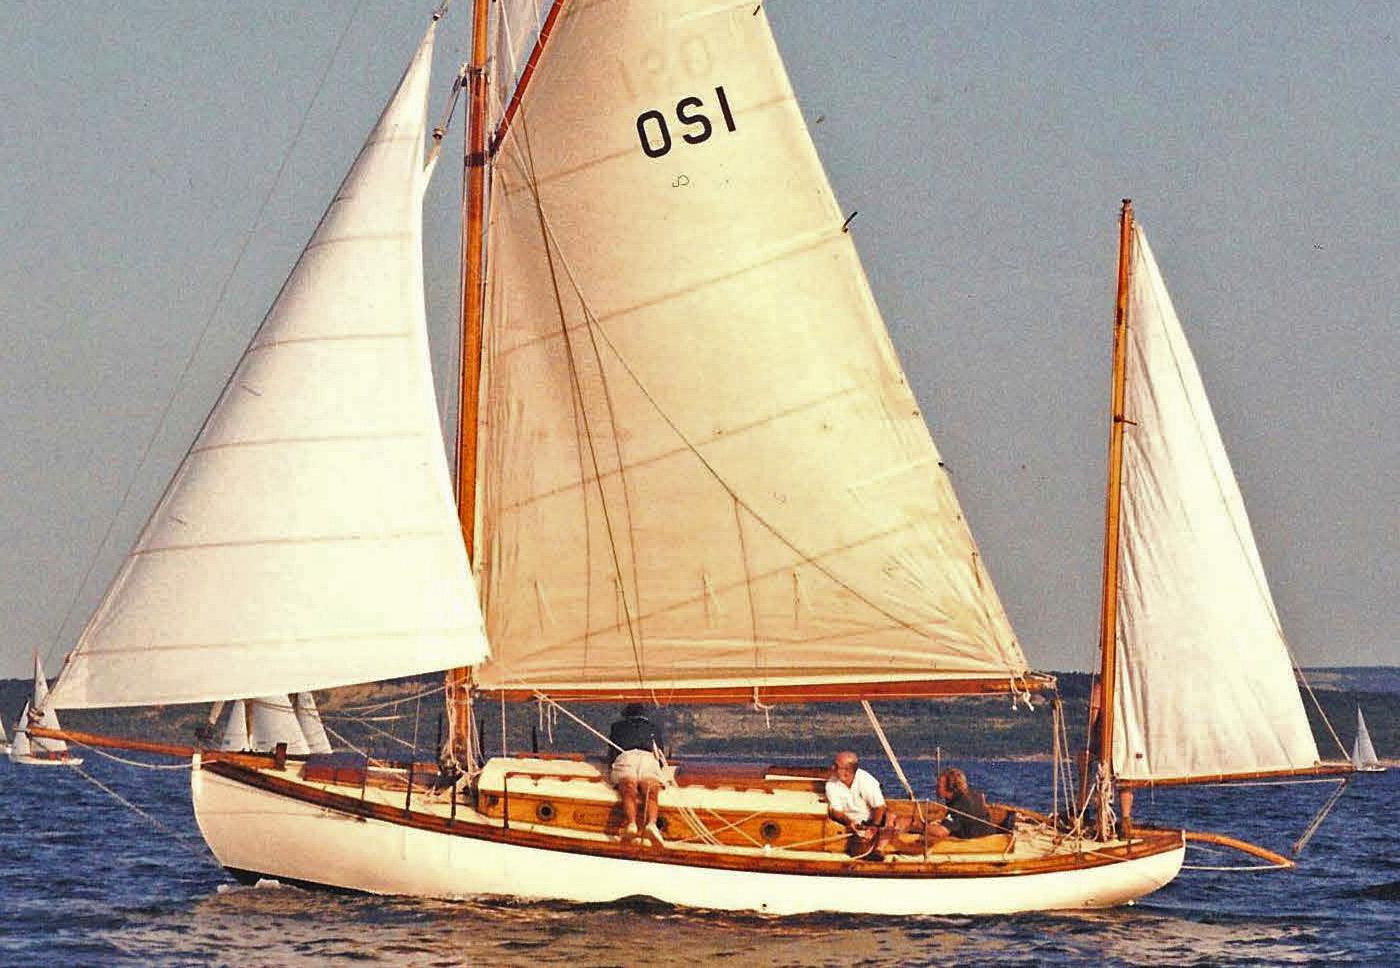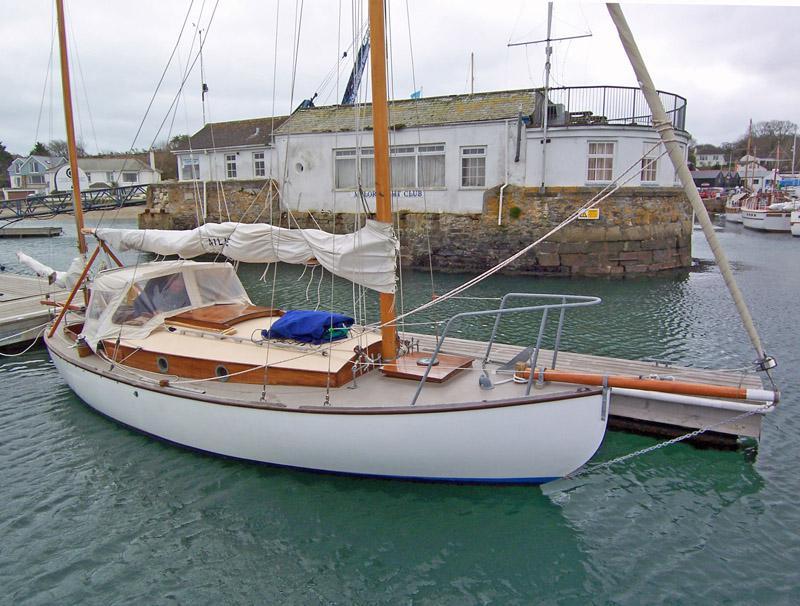The first image is the image on the left, the second image is the image on the right. Given the left and right images, does the statement "There is a docked boat in the water whos sail is not deployed." hold true? Answer yes or no. Yes. The first image is the image on the left, the second image is the image on the right. Analyze the images presented: Is the assertion "An image shows a white-sailed boat creating white spray as it moves through the water." valid? Answer yes or no. No. 